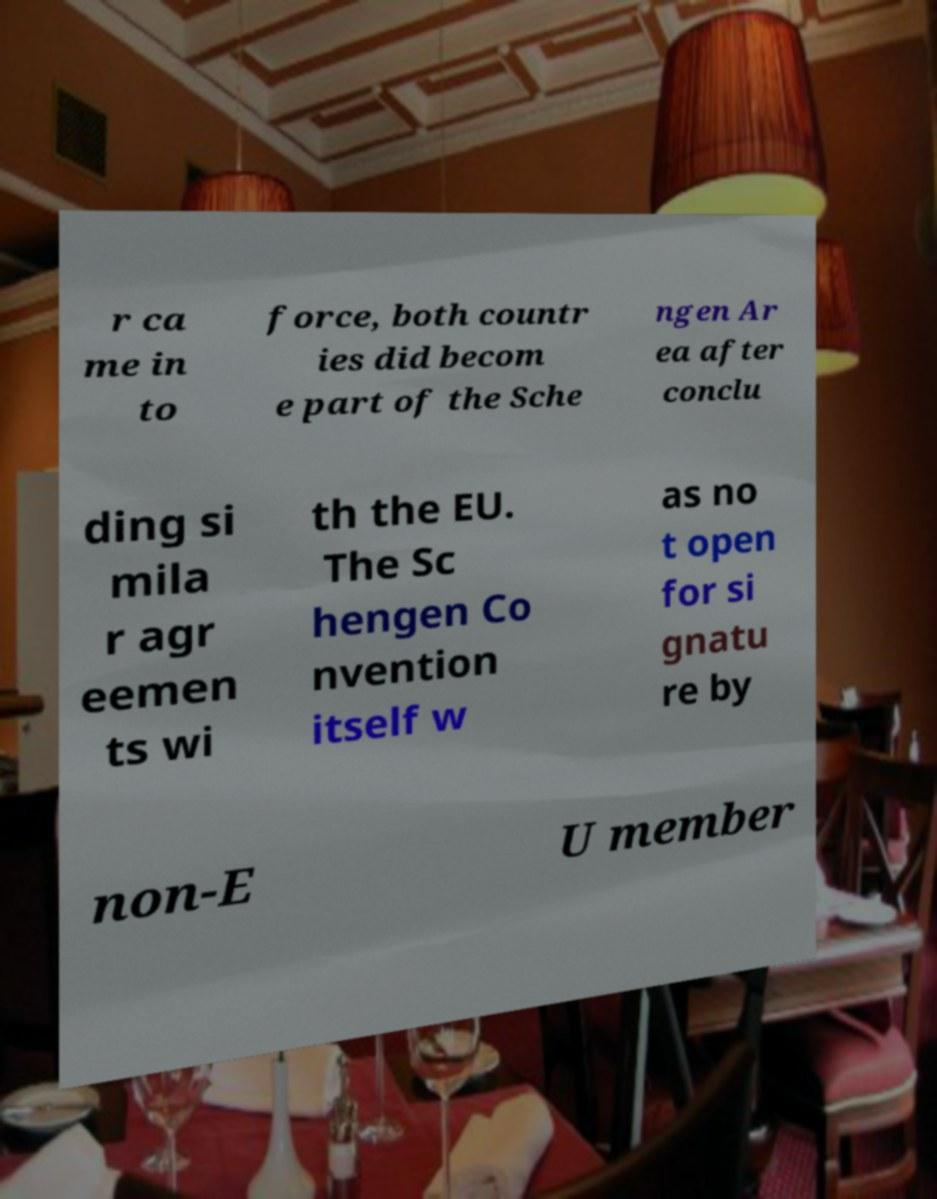What messages or text are displayed in this image? I need them in a readable, typed format. r ca me in to force, both countr ies did becom e part of the Sche ngen Ar ea after conclu ding si mila r agr eemen ts wi th the EU. The Sc hengen Co nvention itself w as no t open for si gnatu re by non-E U member 